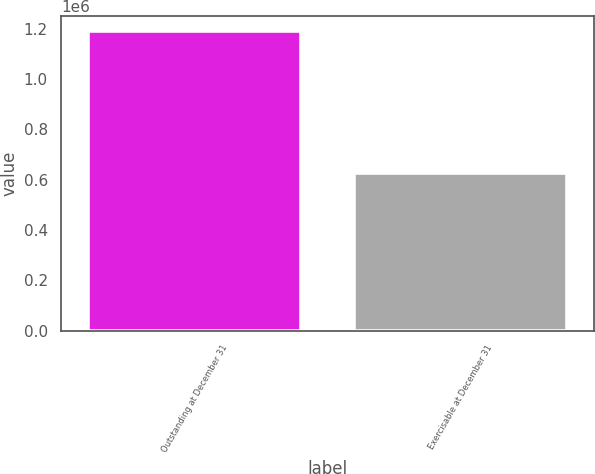Convert chart. <chart><loc_0><loc_0><loc_500><loc_500><bar_chart><fcel>Outstanding at December 31<fcel>Exercisable at December 31<nl><fcel>1.19054e+06<fcel>625470<nl></chart> 